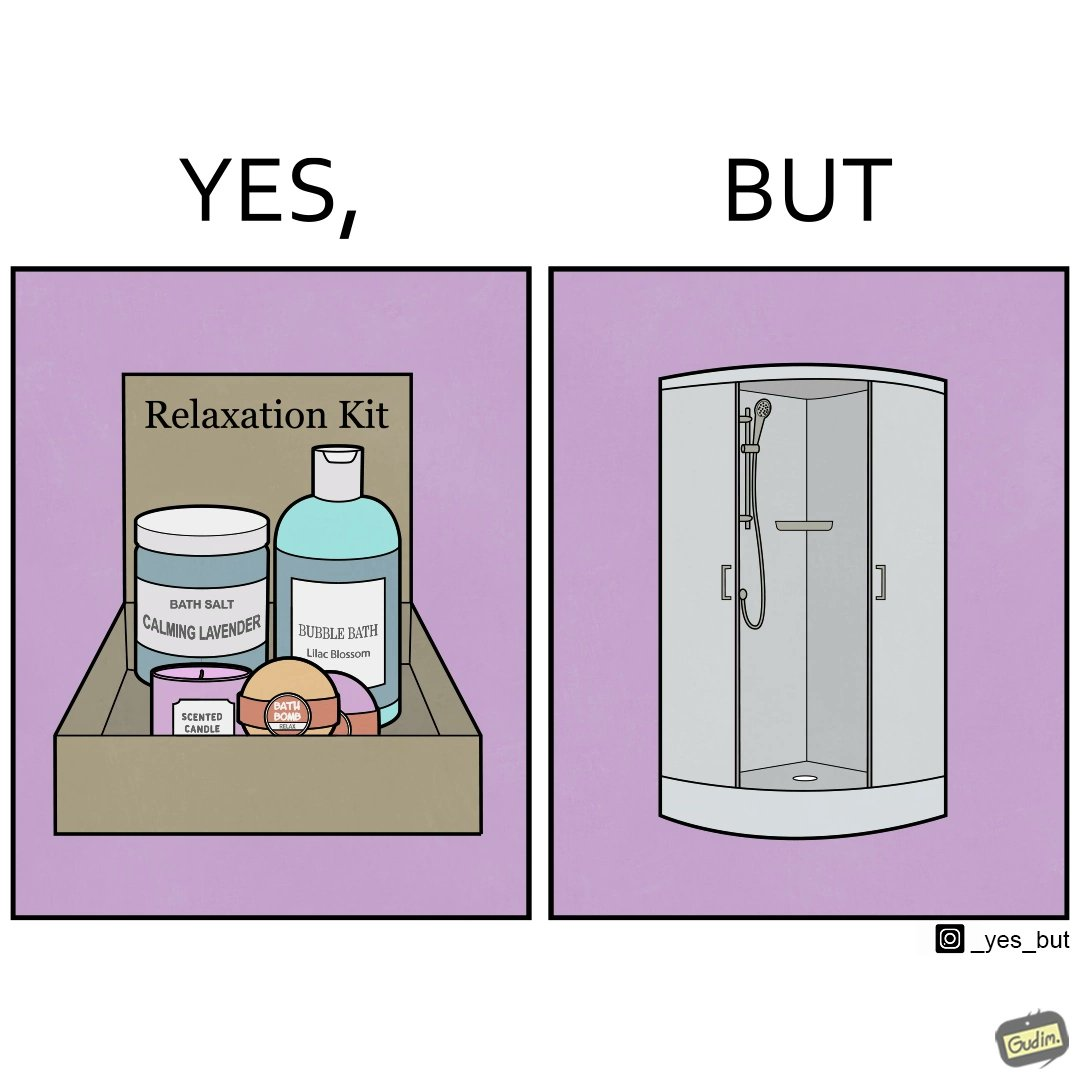Explain why this image is satirical. The image is ironical, as the relaxation kit is meant to relax and calm down the person using it during a bath, but the showering area is an enclosed space, which might instead tense up someone, especially if the person is claustrophobic. 